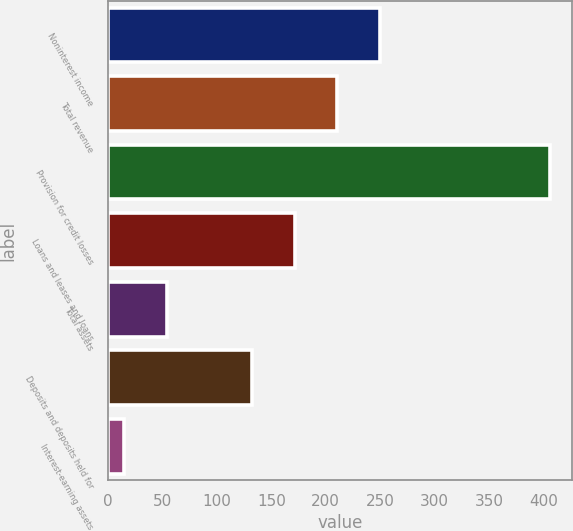Convert chart. <chart><loc_0><loc_0><loc_500><loc_500><bar_chart><fcel>Noninterest income<fcel>Total revenue<fcel>Provision for credit losses<fcel>Loans and leases and loans<fcel>Total assets<fcel>Deposits and deposits held for<fcel>Interest-earning assets<nl><fcel>249.6<fcel>210.5<fcel>406<fcel>171.4<fcel>54.1<fcel>132.3<fcel>15<nl></chart> 